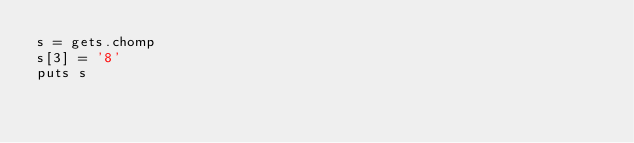<code> <loc_0><loc_0><loc_500><loc_500><_Ruby_>s = gets.chomp
s[3] = '8'
puts s</code> 